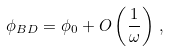Convert formula to latex. <formula><loc_0><loc_0><loc_500><loc_500>\phi _ { B D } = \phi _ { 0 } + O \left ( \frac { 1 } { \omega } \right ) \, ,</formula> 